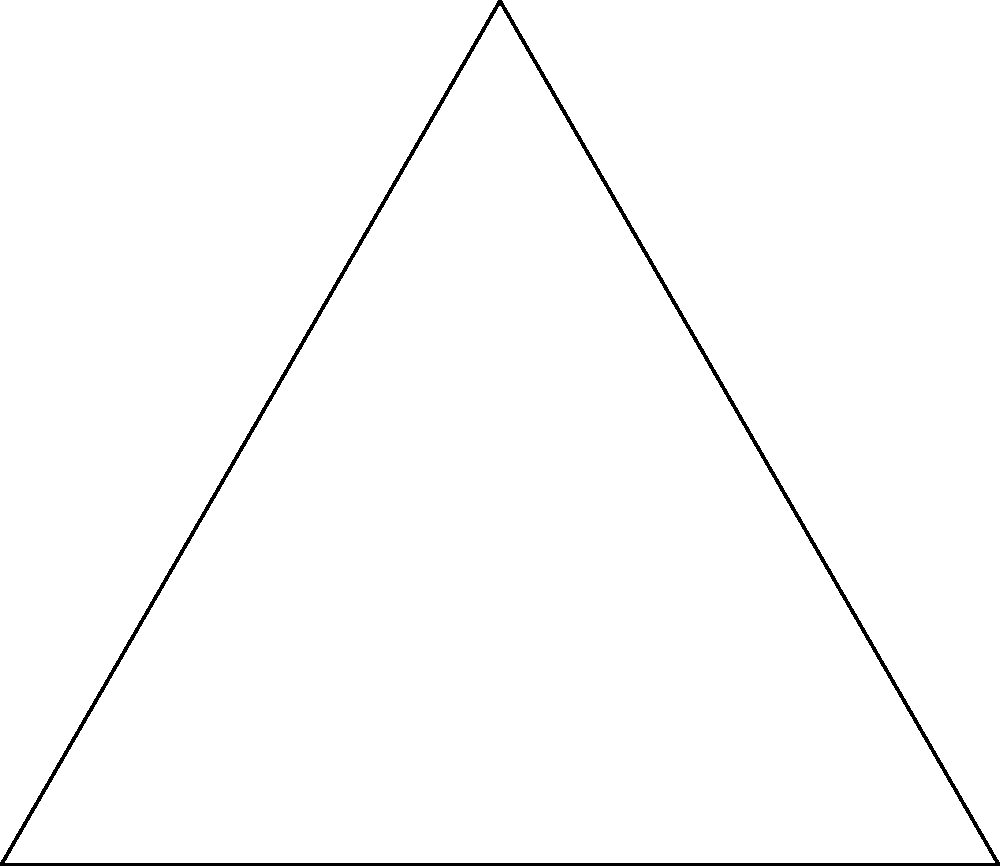As you reflect on your geometry classes, consider the equilateral triangle ABC shown above. Identify all symmetry operations that map this triangle onto itself, excluding the identity transformation. Let's approach this step-by-step:

1) Rotational symmetry:
   - The triangle has 3-fold rotational symmetry.
   - It can be rotated by 120° and 240° about its center.

2) Reflection symmetry:
   - There are three lines of reflection symmetry:
     a) The line from vertex A to the midpoint of BC
     b) The line from vertex B to the midpoint of AC
     c) The line from vertex C to the midpoint of AB

3) Counting the symmetry operations:
   - 2 rotations (120° and 240°)
   - 3 reflections

Therefore, there are 5 non-trivial symmetry operations that map the triangle onto itself.

Note: The identity transformation (0° rotation or no reflection) is excluded as per the question.
Answer: 5 symmetry operations: 2 rotations and 3 reflections 